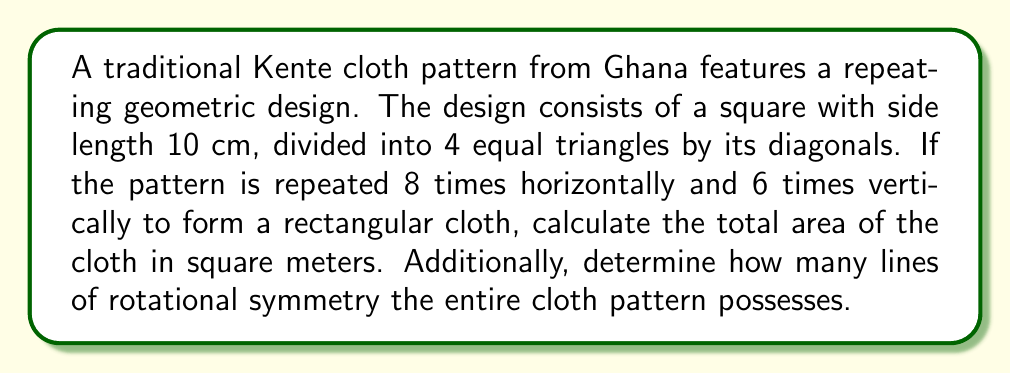Could you help me with this problem? Let's approach this problem step-by-step:

1. Calculate the area of a single square design:
   Area of square = $10 \text{ cm} \times 10 \text{ cm} = 100 \text{ cm}^2$

2. Determine the number of squares in the entire cloth:
   Horizontal squares = 8
   Vertical squares = 6
   Total squares = $8 \times 6 = 48$

3. Calculate the total area of the cloth in square centimeters:
   Total area = $48 \times 100 \text{ cm}^2 = 4800 \text{ cm}^2$

4. Convert the area to square meters:
   $4800 \text{ cm}^2 = 4800 \div 10000 = 0.48 \text{ m}^2$

5. For rotational symmetry, we need to consider the entire cloth pattern:
   - The cloth has 8 squares horizontally and 6 squares vertically.
   - For rotational symmetry, the pattern must look the same after rotation.
   - The cloth will have 2-fold rotational symmetry (180° rotation) because it's rectangular.
   - It will not have 4-fold rotational symmetry (90° rotation) because 8 ≠ 6.

Therefore, the cloth pattern has 1 line of rotational symmetry (180° rotation).

[asy]
size(200);
for(int i=0; i<8; ++i) {
  for(int j=0; j<6; ++j) {
    draw((i*10,j*10)--(i*10+10,j*10)--(i*10+10,j*10+10)--(i*10,j*10+10)--cycle);
    draw((i*10,j*10)--(i*10+10,j*10+10));
    draw((i*10,j*10+10)--(i*10+10,j*10));
  }
}
[/asy]
Answer: The total area of the cloth is $0.48 \text{ m}^2$, and the entire cloth pattern possesses 1 line of rotational symmetry. 